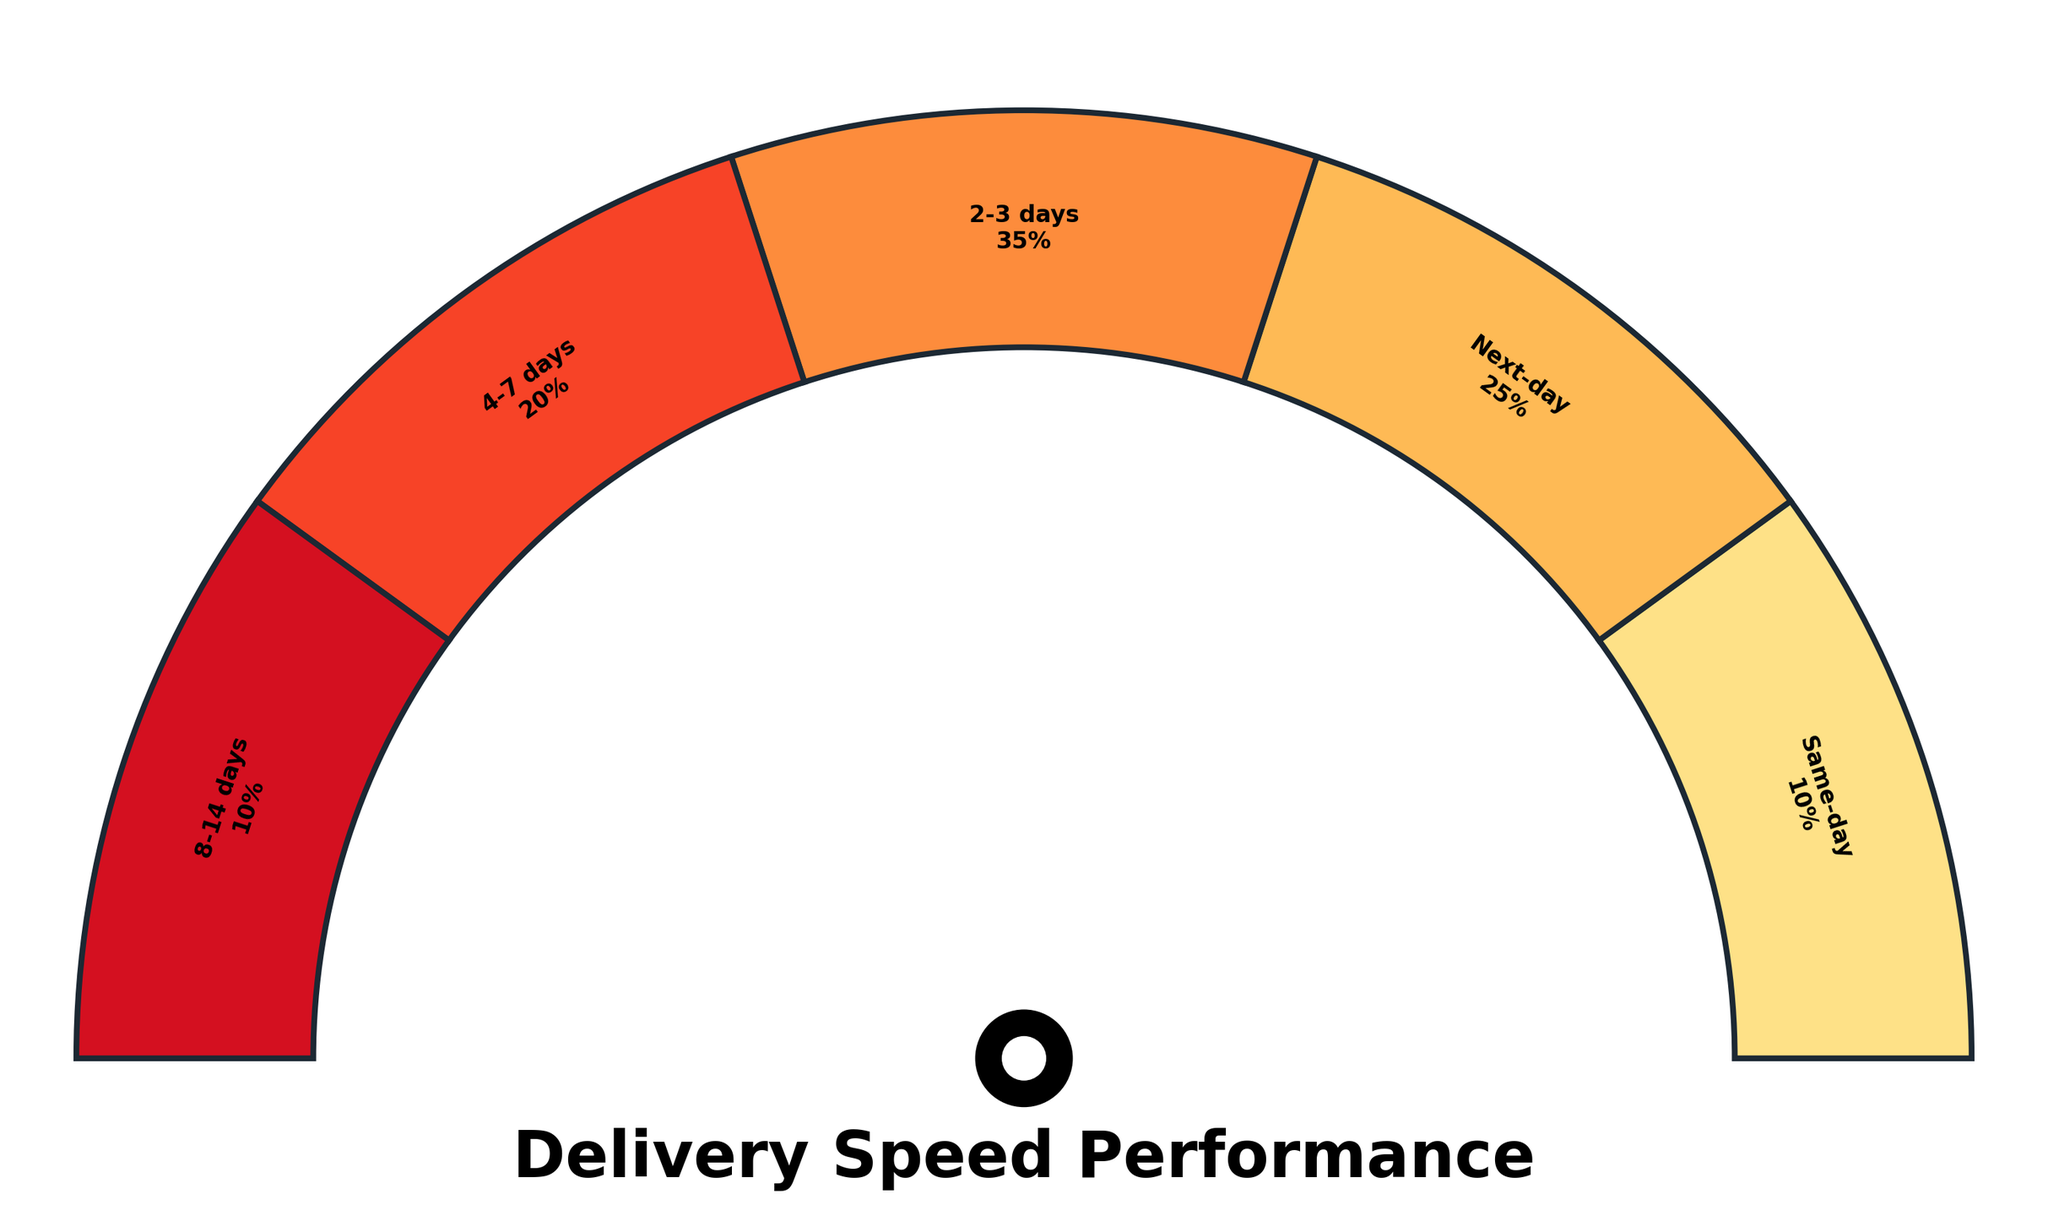What's the title of the chart? The title is centered below the main part of the figure in large, bold text.
Answer: Delivery Speed Performance How many delivery time categories are shown on the gauge chart? Each distinct segment on the gauge chart represents a delivery time category. Counting these segments gives us the number of categories.
Answer: 5 Which delivery time category has the highest percentage? Look for the segment with the longest arc on the chart. The label next to it indicates the delivery time category with the highest percentage.
Answer: 2-3 days What percentage of deliveries are made within the first three days (same-day and next-day combined)? Sum the percentages of the "Same-day" and "Next-day" delivery categories shown on the chart.
Answer: 35% What are the colors used in the gauge chart? The colors can be observed visually: various shades of yellow, orange, and red. The darkest shade likely represents the longer delivery times.
Answer: Shades of yellow, orange, and red Which delivery time categories together make up half of the delivery percentages? Start adding the percentages from the highest to the lowest until you reach or exceed 50%. Categories within this total form the answer.
Answer: 2-3 days and Next-day (35% + 25% = 60%) Compare the delivery percentages of the "4-7 days" and "8-14 days" categories. Which is greater and by how much? Identify the percentages of the "4-7 days" and "8-14 days" segments, then subtract the smaller percentage from the larger one.
Answer: 4-7 days is greater by 10% What representation is used for each delivery time category on the chart? Each category is depicted as a wedge, or arc segment, with its own color and label.
Answer: Wedge/arc segments Is the combined percentage of deliveries after 3 days more or less than 50%? Sum the percentages of the "4-7 days" and "8-14 days" categories and compare the result to 50%.
Answer: Less (30%) 